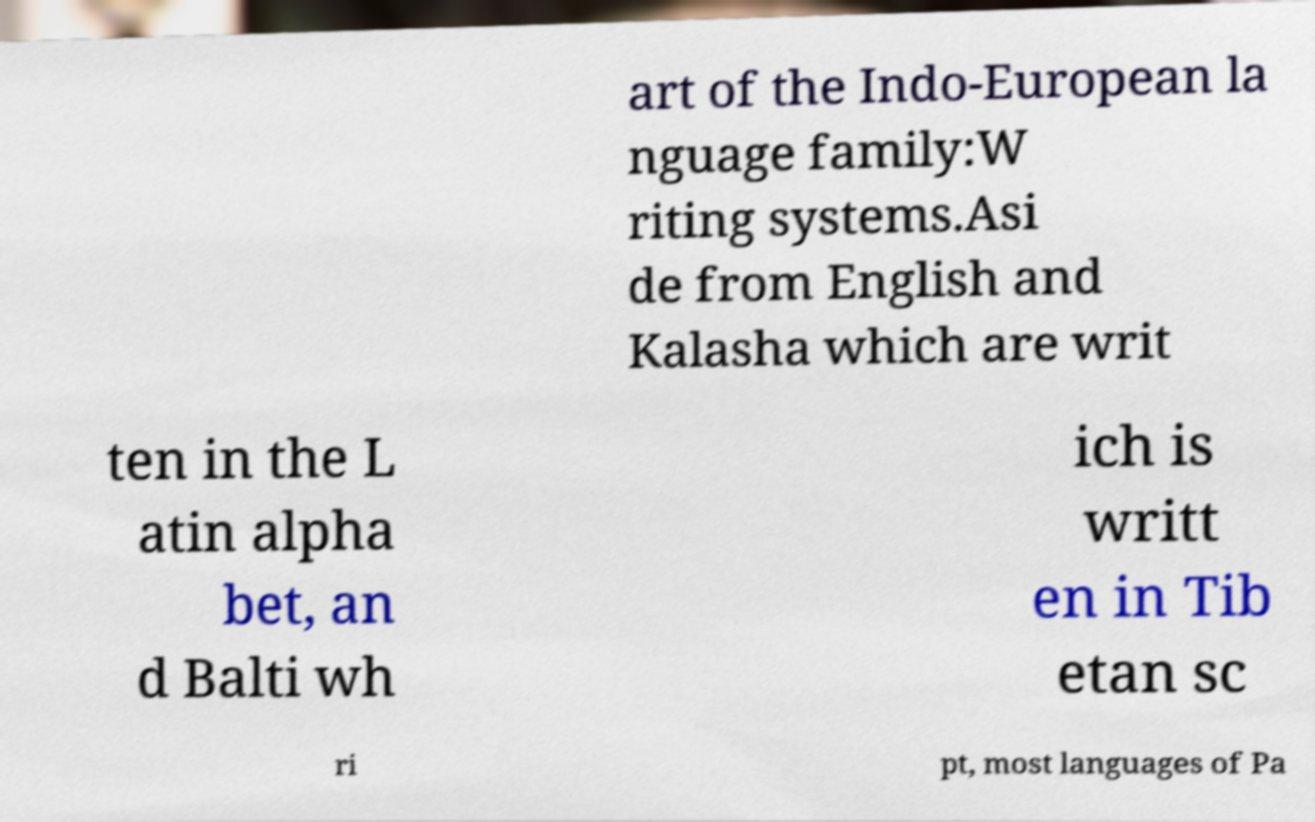Please identify and transcribe the text found in this image. art of the Indo-European la nguage family:W riting systems.Asi de from English and Kalasha which are writ ten in the L atin alpha bet, an d Balti wh ich is writt en in Tib etan sc ri pt, most languages of Pa 